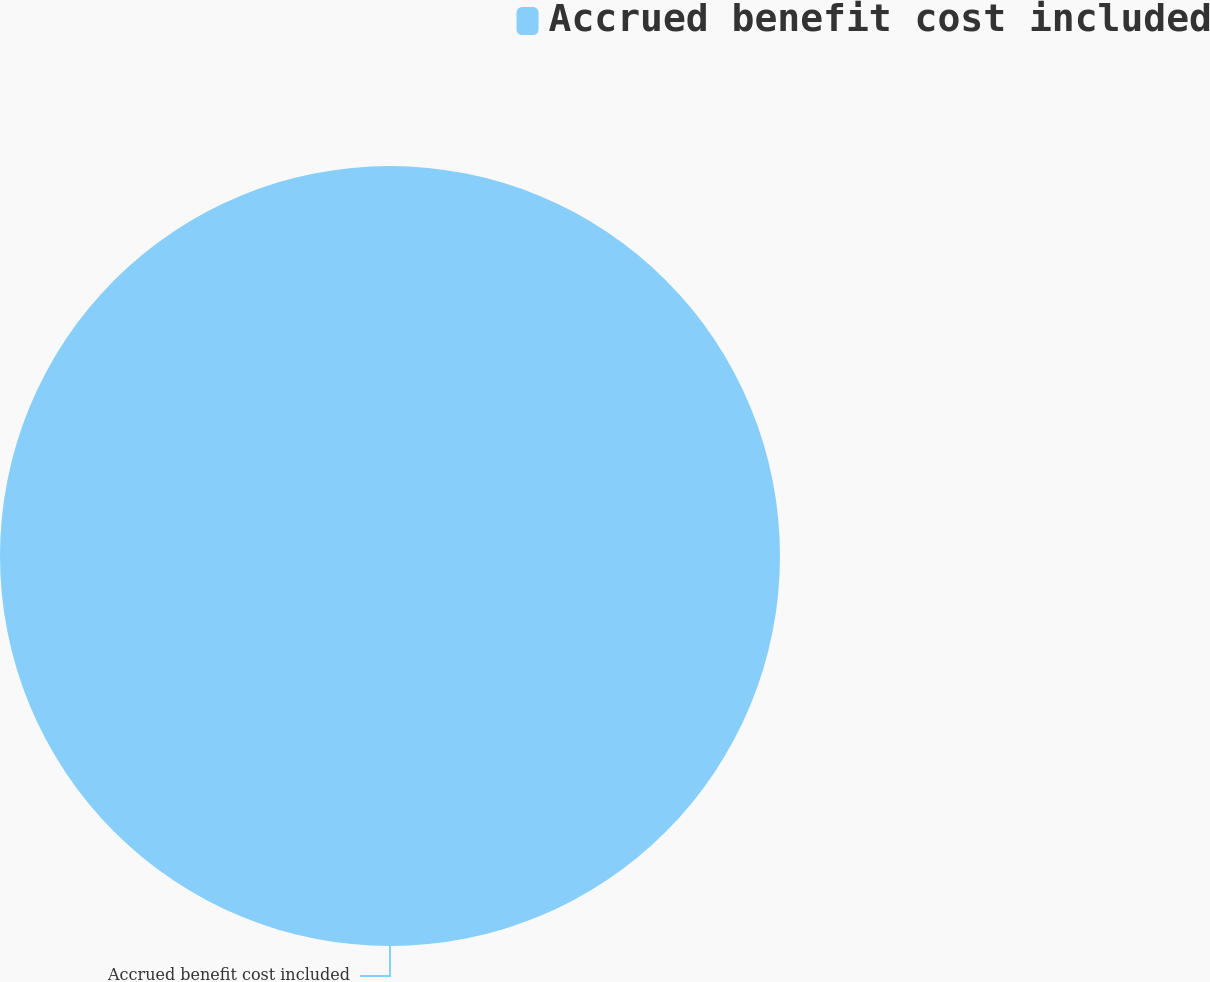Convert chart to OTSL. <chart><loc_0><loc_0><loc_500><loc_500><pie_chart><fcel>Accrued benefit cost included<nl><fcel>100.0%<nl></chart> 